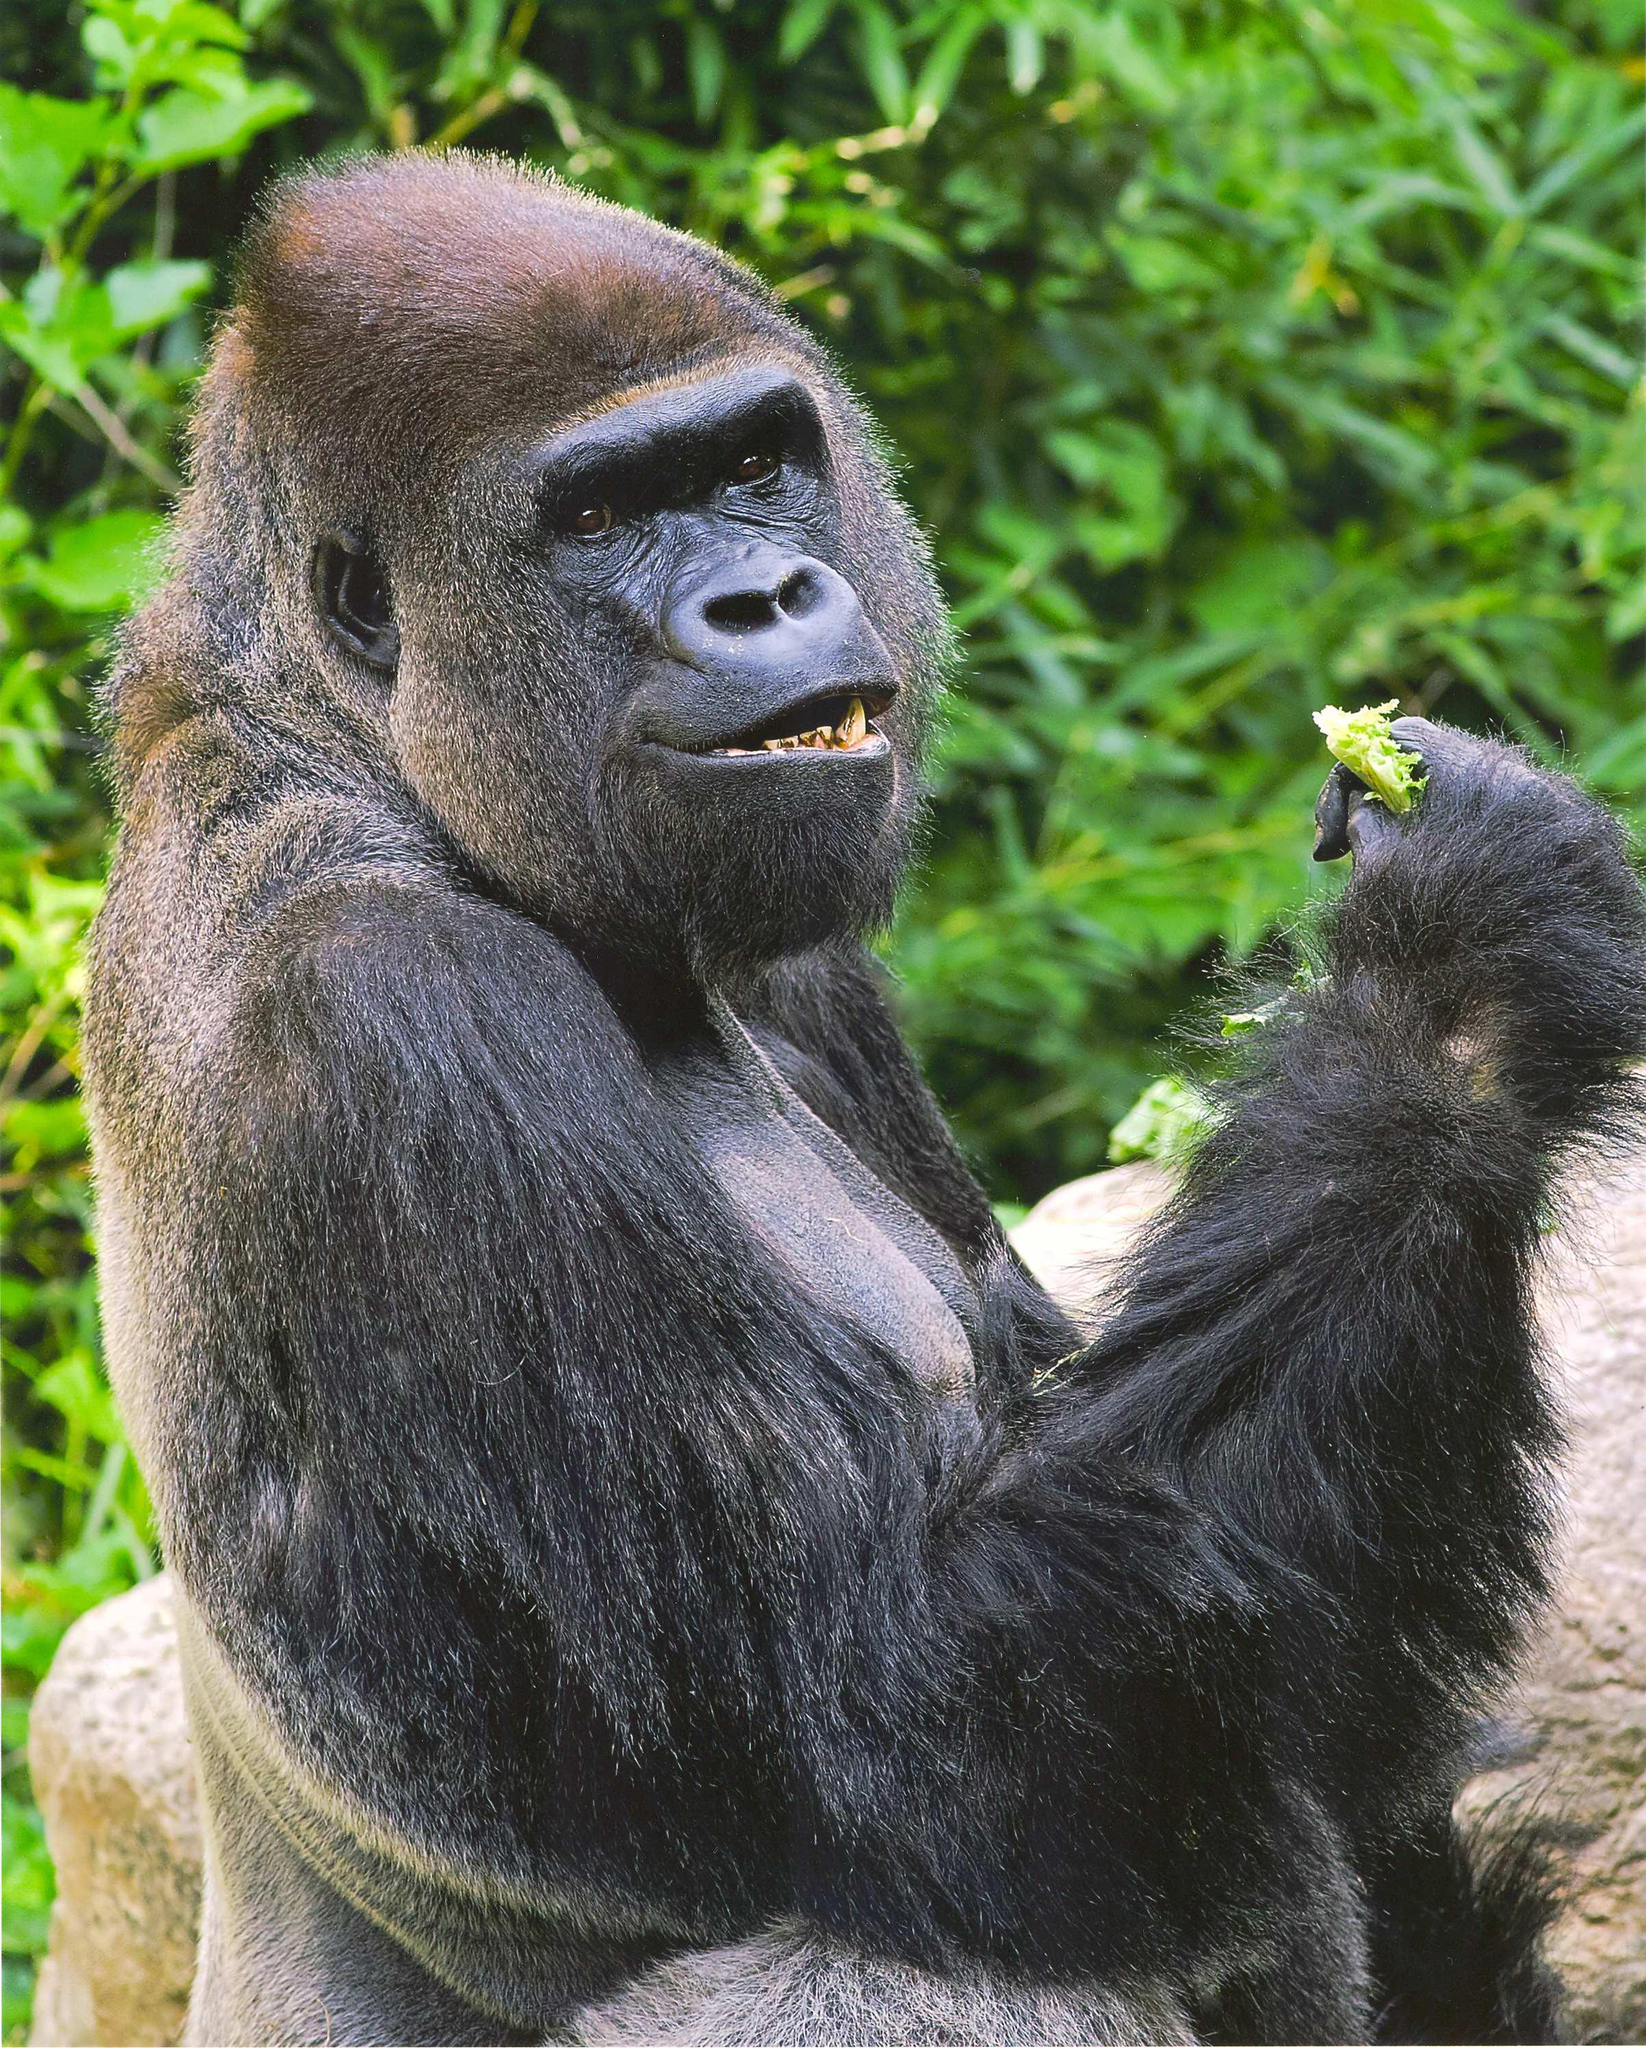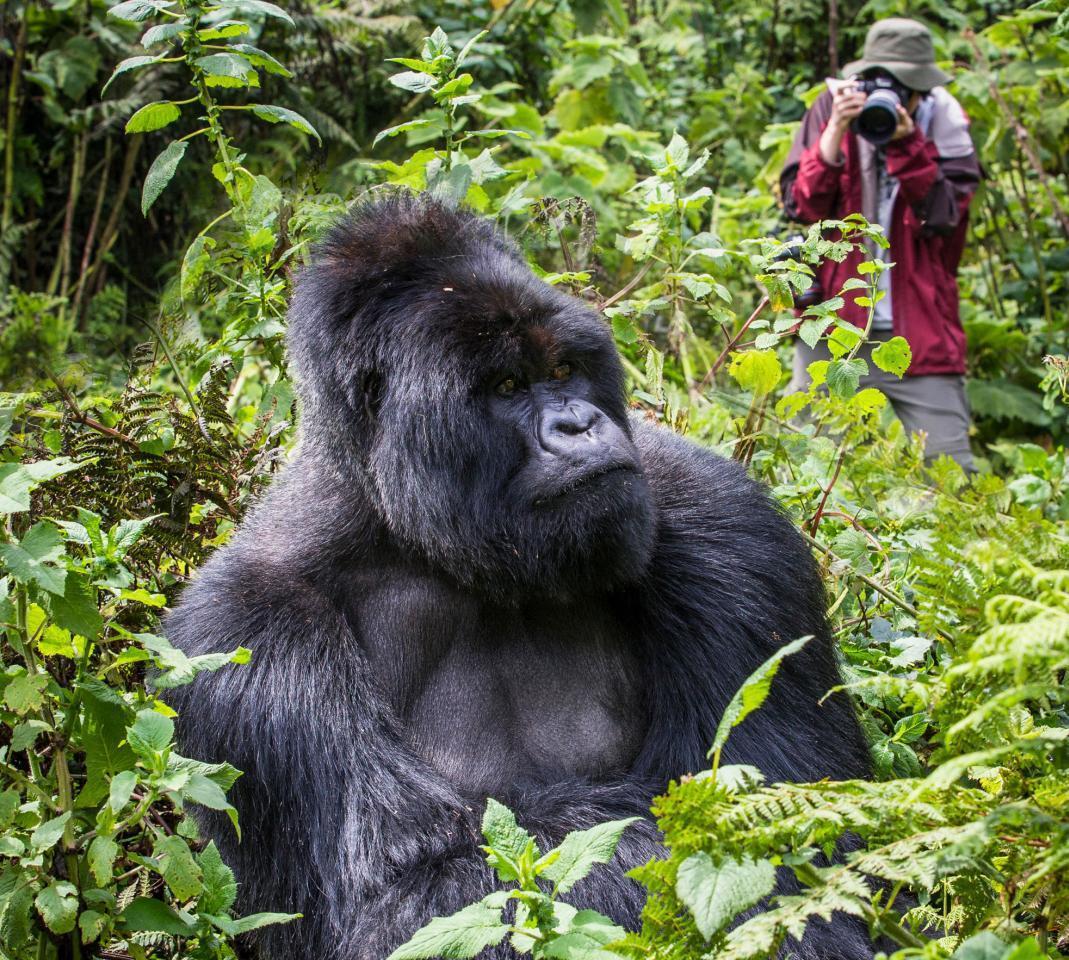The first image is the image on the left, the second image is the image on the right. Examine the images to the left and right. Is the description "the left and right image contains the same number of gorillas." accurate? Answer yes or no. Yes. 